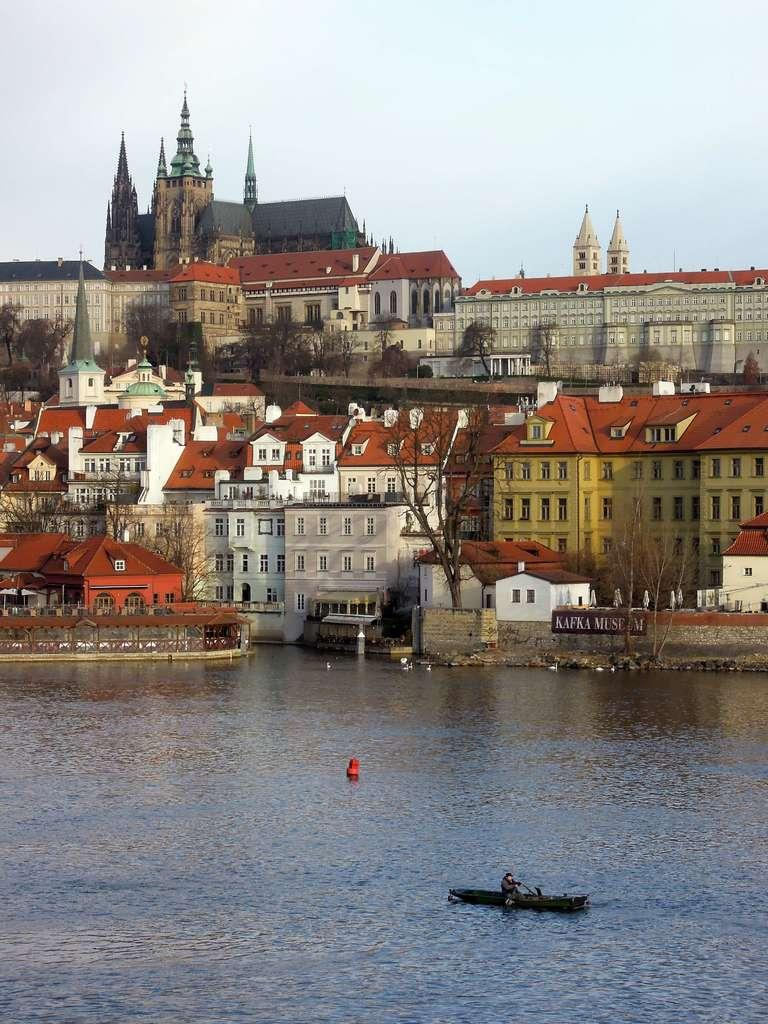What is present at the bottom of the image? There is water at the bottom side of the image. What can be seen in the distance in the image? There are buildings and trees in the background of the image. Who is the creator of the wheel in the image? There is no wheel present in the image, so it is not possible to determine who created it. 